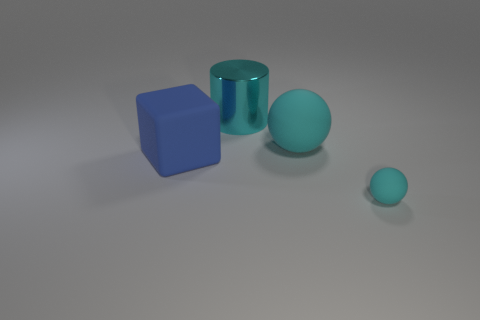Subtract 0 red spheres. How many objects are left? 4 Subtract all cylinders. How many objects are left? 3 Subtract 1 cylinders. How many cylinders are left? 0 Subtract all gray balls. Subtract all purple cylinders. How many balls are left? 2 Subtract all big blue matte objects. Subtract all big metal cylinders. How many objects are left? 2 Add 1 tiny spheres. How many tiny spheres are left? 2 Add 2 big shiny cylinders. How many big shiny cylinders exist? 3 Add 4 large cyan metal cylinders. How many objects exist? 8 